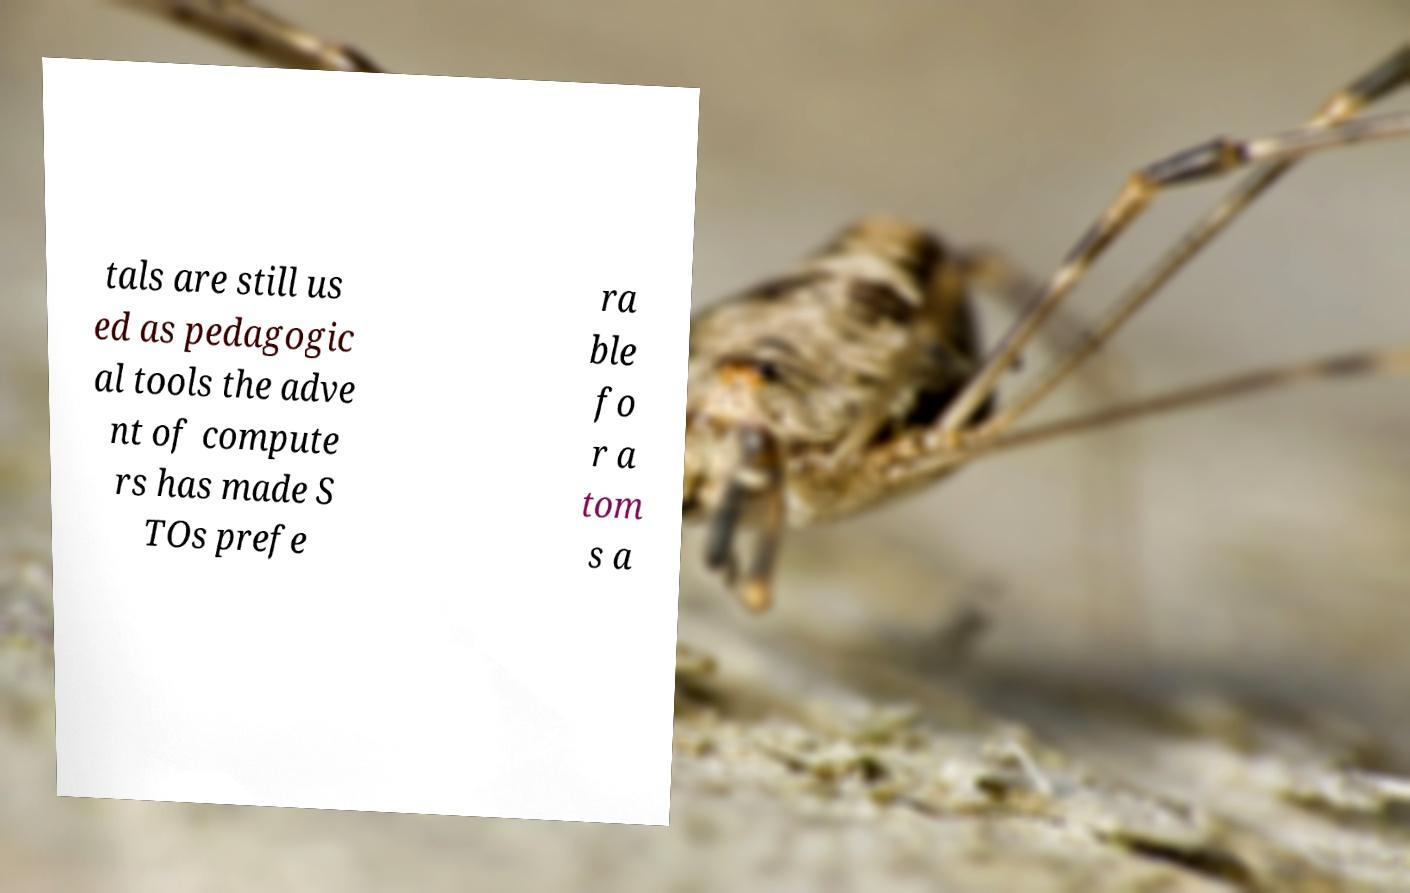For documentation purposes, I need the text within this image transcribed. Could you provide that? tals are still us ed as pedagogic al tools the adve nt of compute rs has made S TOs prefe ra ble fo r a tom s a 